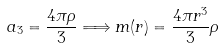<formula> <loc_0><loc_0><loc_500><loc_500>a _ { 3 } = \frac { 4 \pi \rho } 3 \Longrightarrow m ( r ) = \frac { 4 \pi r ^ { 3 } } 3 \rho</formula> 